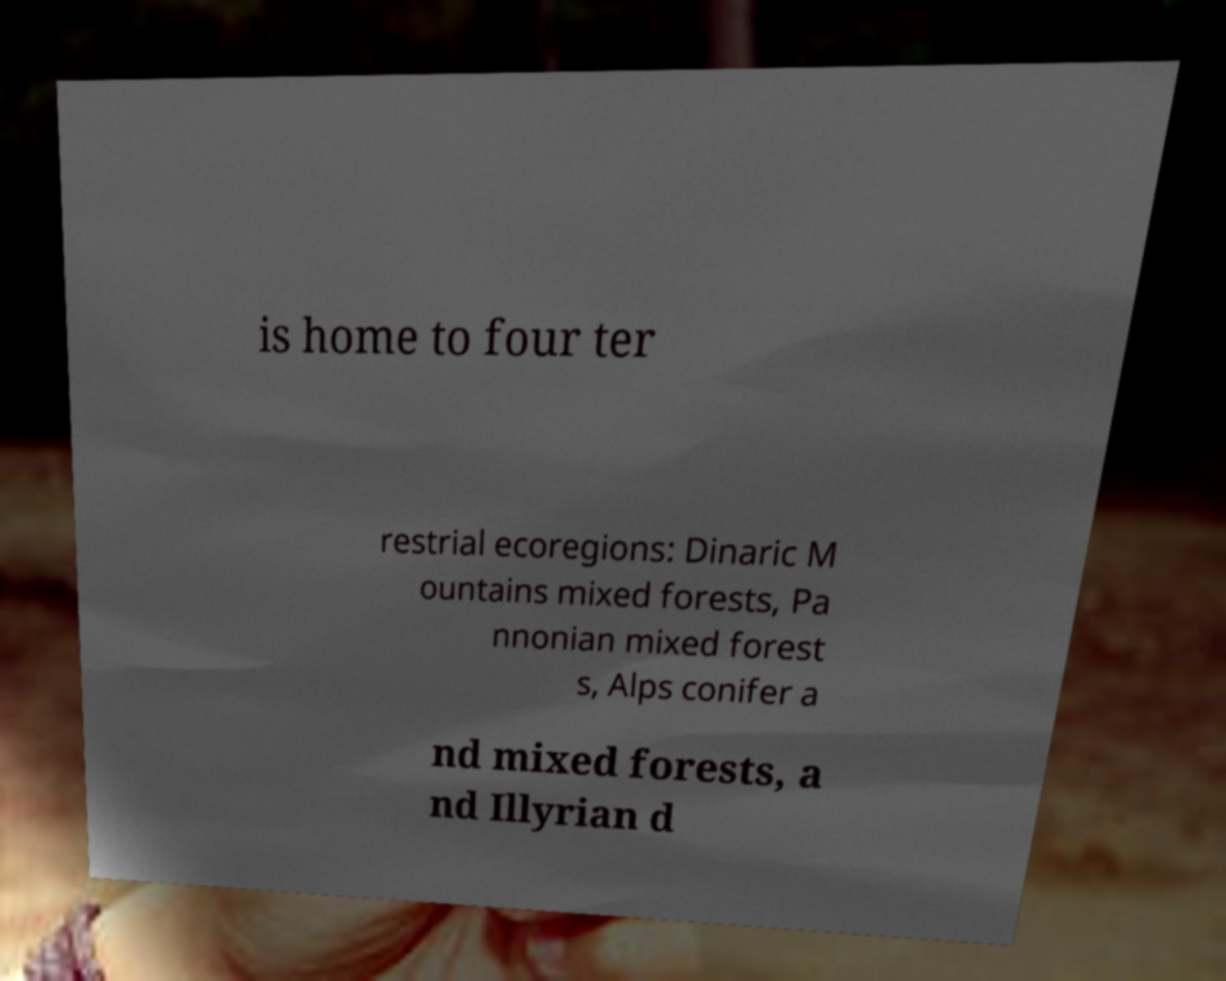Can you accurately transcribe the text from the provided image for me? is home to four ter restrial ecoregions: Dinaric M ountains mixed forests, Pa nnonian mixed forest s, Alps conifer a nd mixed forests, a nd Illyrian d 